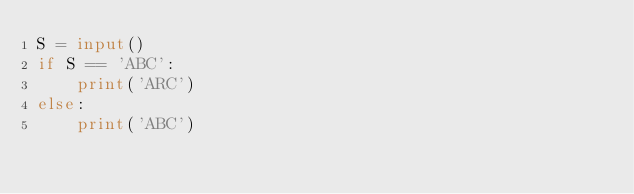Convert code to text. <code><loc_0><loc_0><loc_500><loc_500><_Python_>S = input()
if S == 'ABC':
    print('ARC')
else:
    print('ABC')</code> 